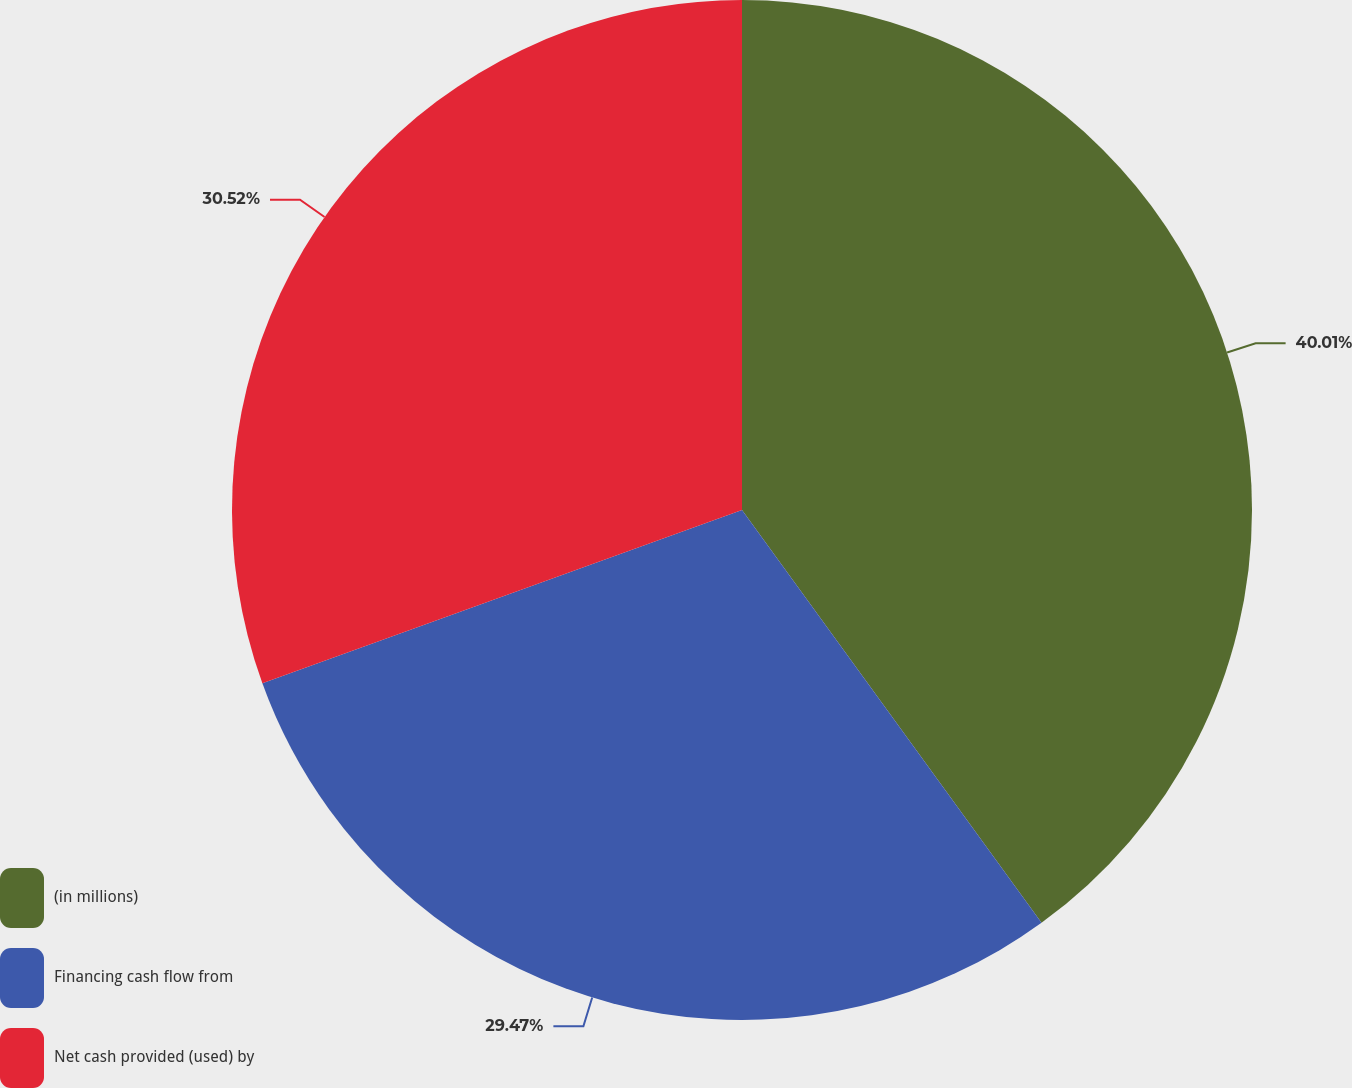Convert chart. <chart><loc_0><loc_0><loc_500><loc_500><pie_chart><fcel>(in millions)<fcel>Financing cash flow from<fcel>Net cash provided (used) by<nl><fcel>40.01%<fcel>29.47%<fcel>30.52%<nl></chart> 